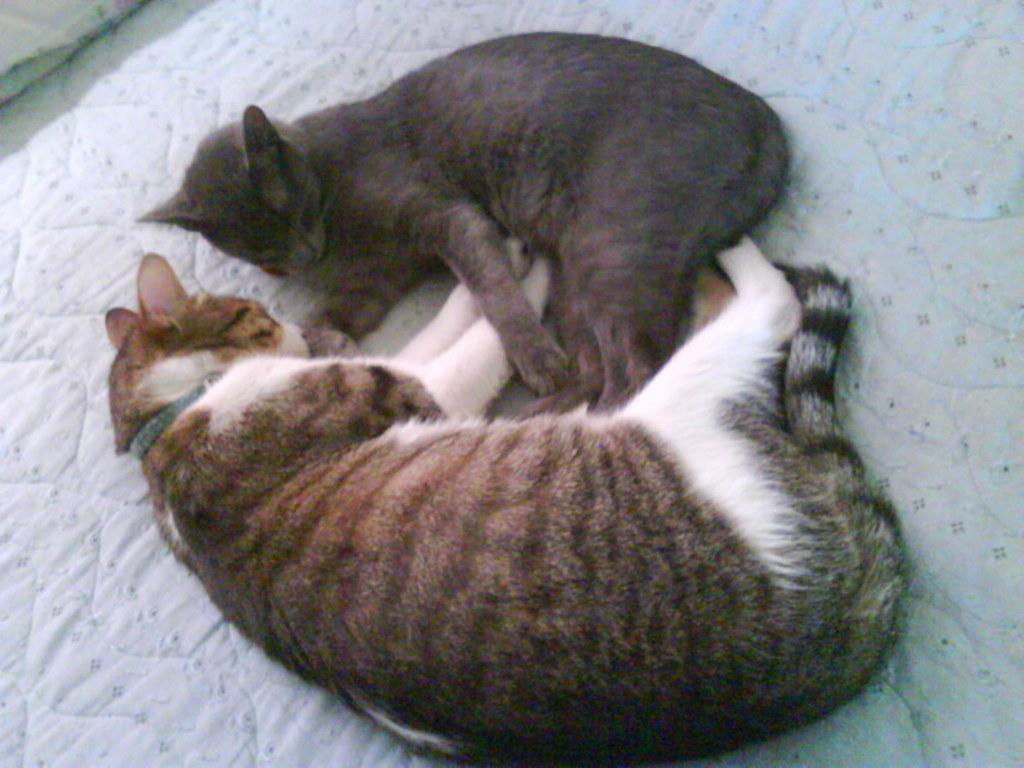Describe this image in one or two sentences. In this image there are two cats sleeping on a mattress. 